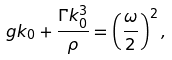Convert formula to latex. <formula><loc_0><loc_0><loc_500><loc_500>g k _ { 0 } + \frac { \Gamma k _ { 0 } ^ { 3 } } { \rho } = \left ( \frac { \omega } { 2 } \right ) ^ { 2 } ,</formula> 